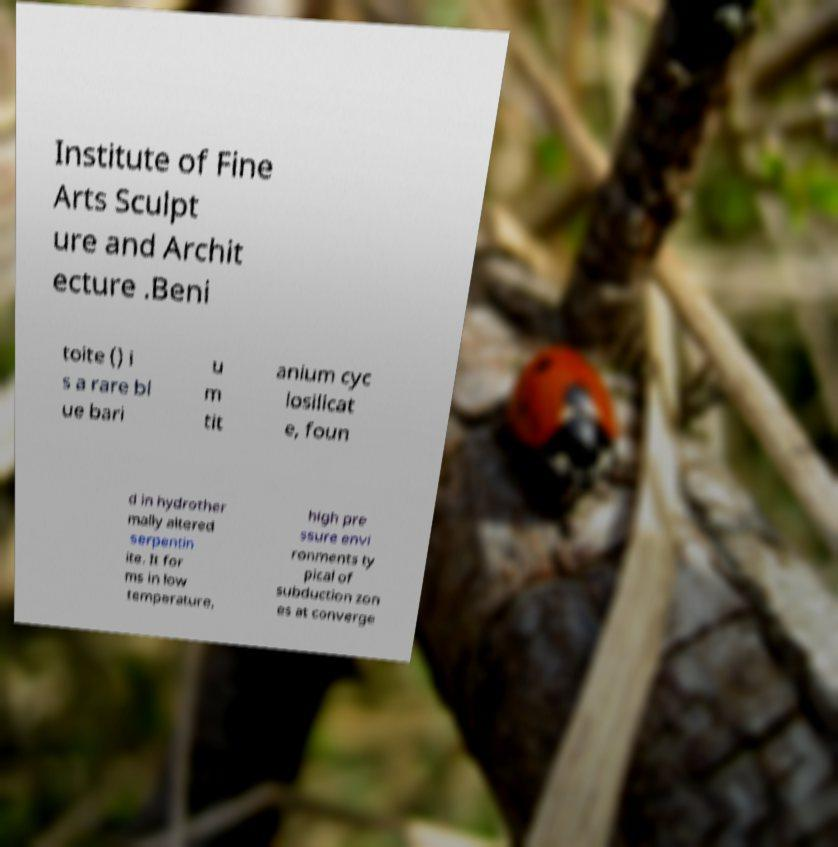For documentation purposes, I need the text within this image transcribed. Could you provide that? Institute of Fine Arts Sculpt ure and Archit ecture .Beni toite () i s a rare bl ue bari u m tit anium cyc losilicat e, foun d in hydrother mally altered serpentin ite. It for ms in low temperature, high pre ssure envi ronments ty pical of subduction zon es at converge 